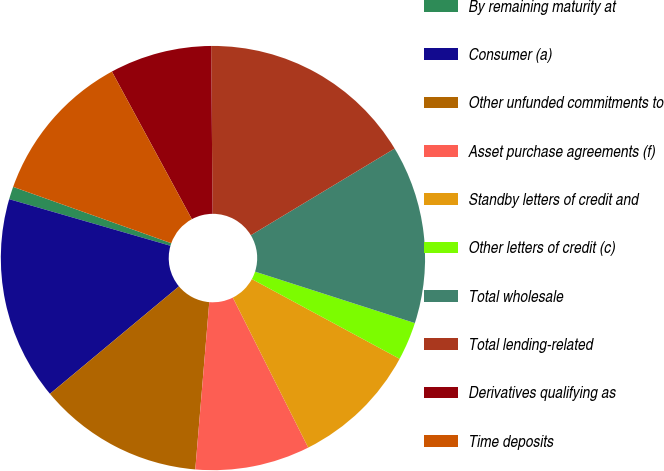Convert chart to OTSL. <chart><loc_0><loc_0><loc_500><loc_500><pie_chart><fcel>By remaining maturity at<fcel>Consumer (a)<fcel>Other unfunded commitments to<fcel>Asset purchase agreements (f)<fcel>Standby letters of credit and<fcel>Other letters of credit (c)<fcel>Total wholesale<fcel>Total lending-related<fcel>Derivatives qualifying as<fcel>Time deposits<nl><fcel>0.97%<fcel>15.53%<fcel>12.62%<fcel>8.74%<fcel>9.71%<fcel>2.92%<fcel>13.59%<fcel>16.5%<fcel>7.77%<fcel>11.65%<nl></chart> 